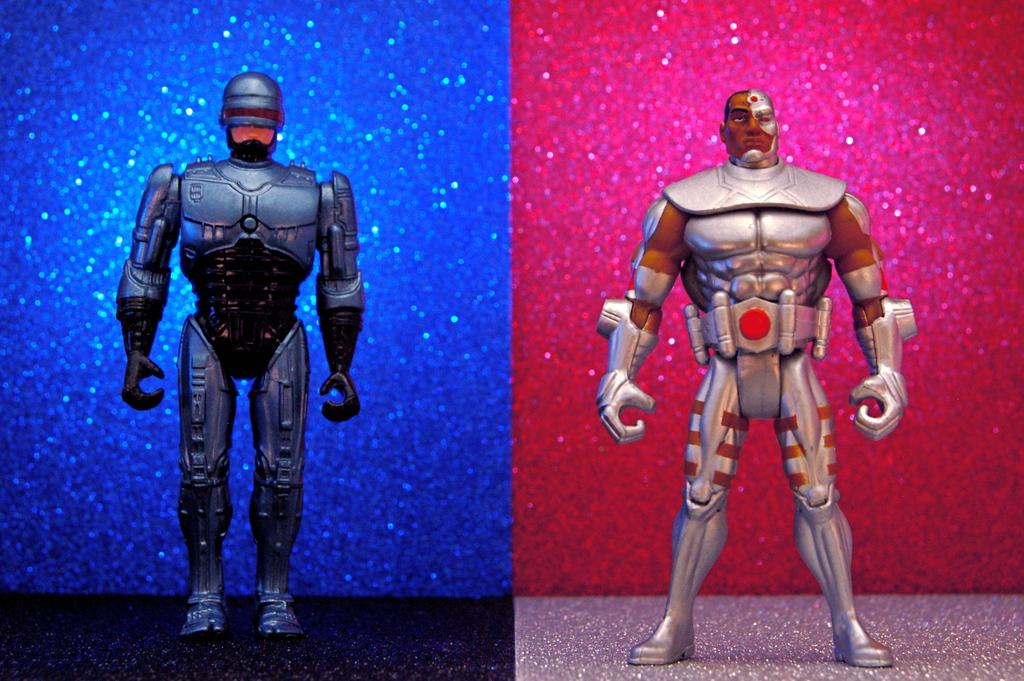What type of artwork is the image? The image is a collage. What can be seen on the left side of the collage? There is an image of a robot on the left side of the collage. What is present on the right side of the collage? There is another image of a robot on the right side of the collage. What type of paper is used to make the crackers in the image? There are no crackers present in the image; it features a collage with two images of robots. How many eggs are visible in the image? There are no eggs visible in the image; it features a collage with two images of robots. 